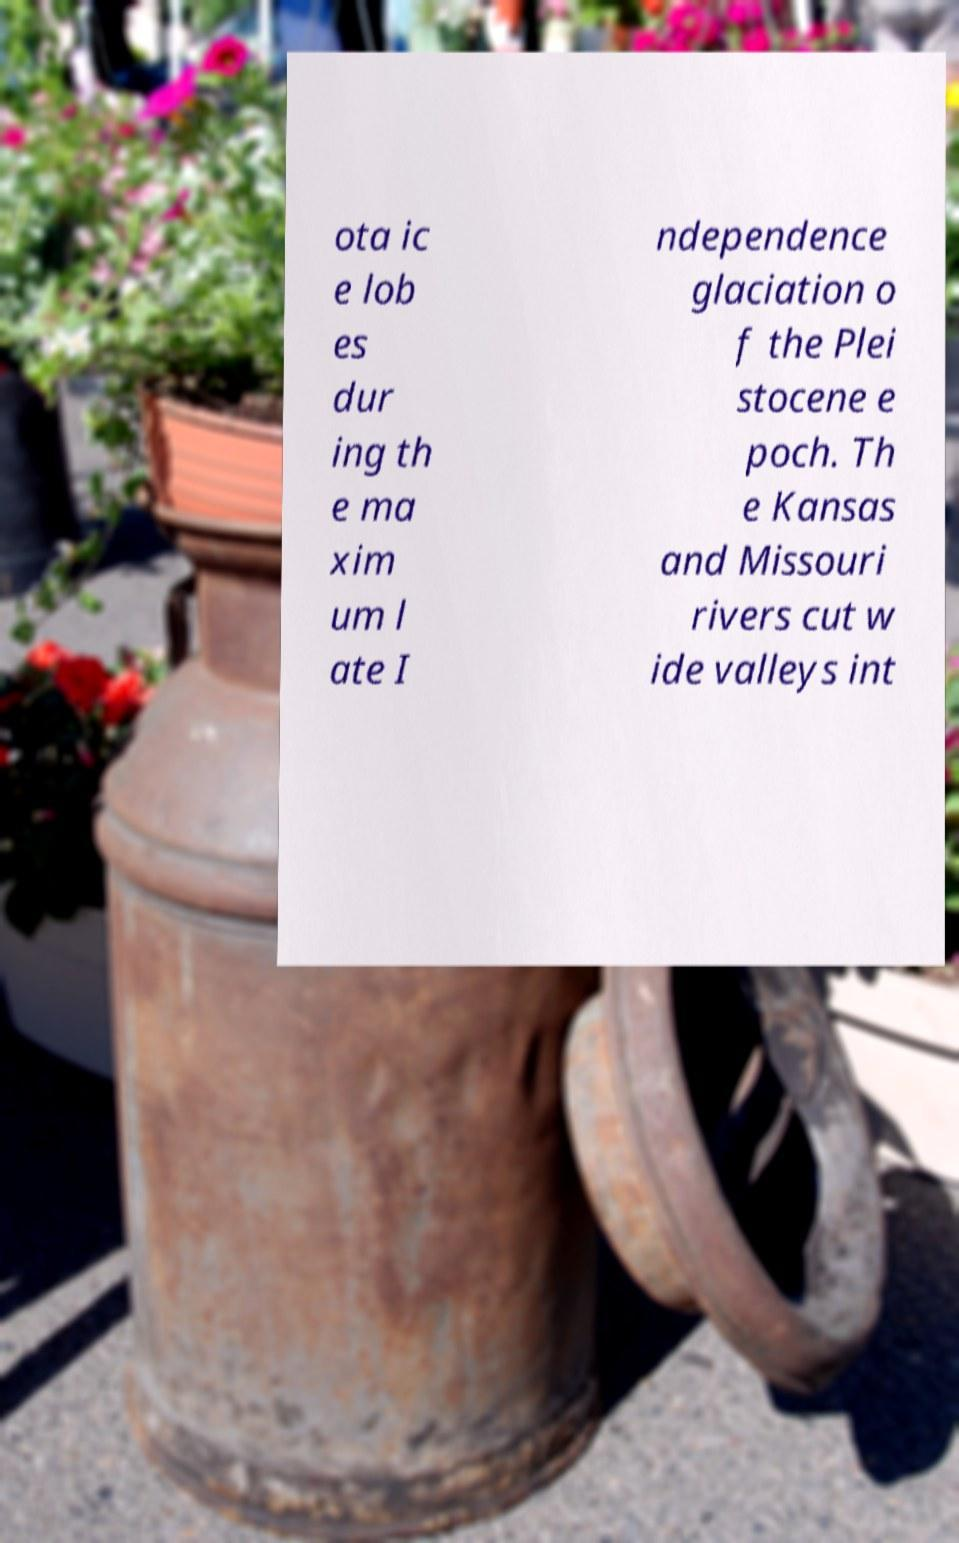Could you extract and type out the text from this image? ota ic e lob es dur ing th e ma xim um l ate I ndependence glaciation o f the Plei stocene e poch. Th e Kansas and Missouri rivers cut w ide valleys int 